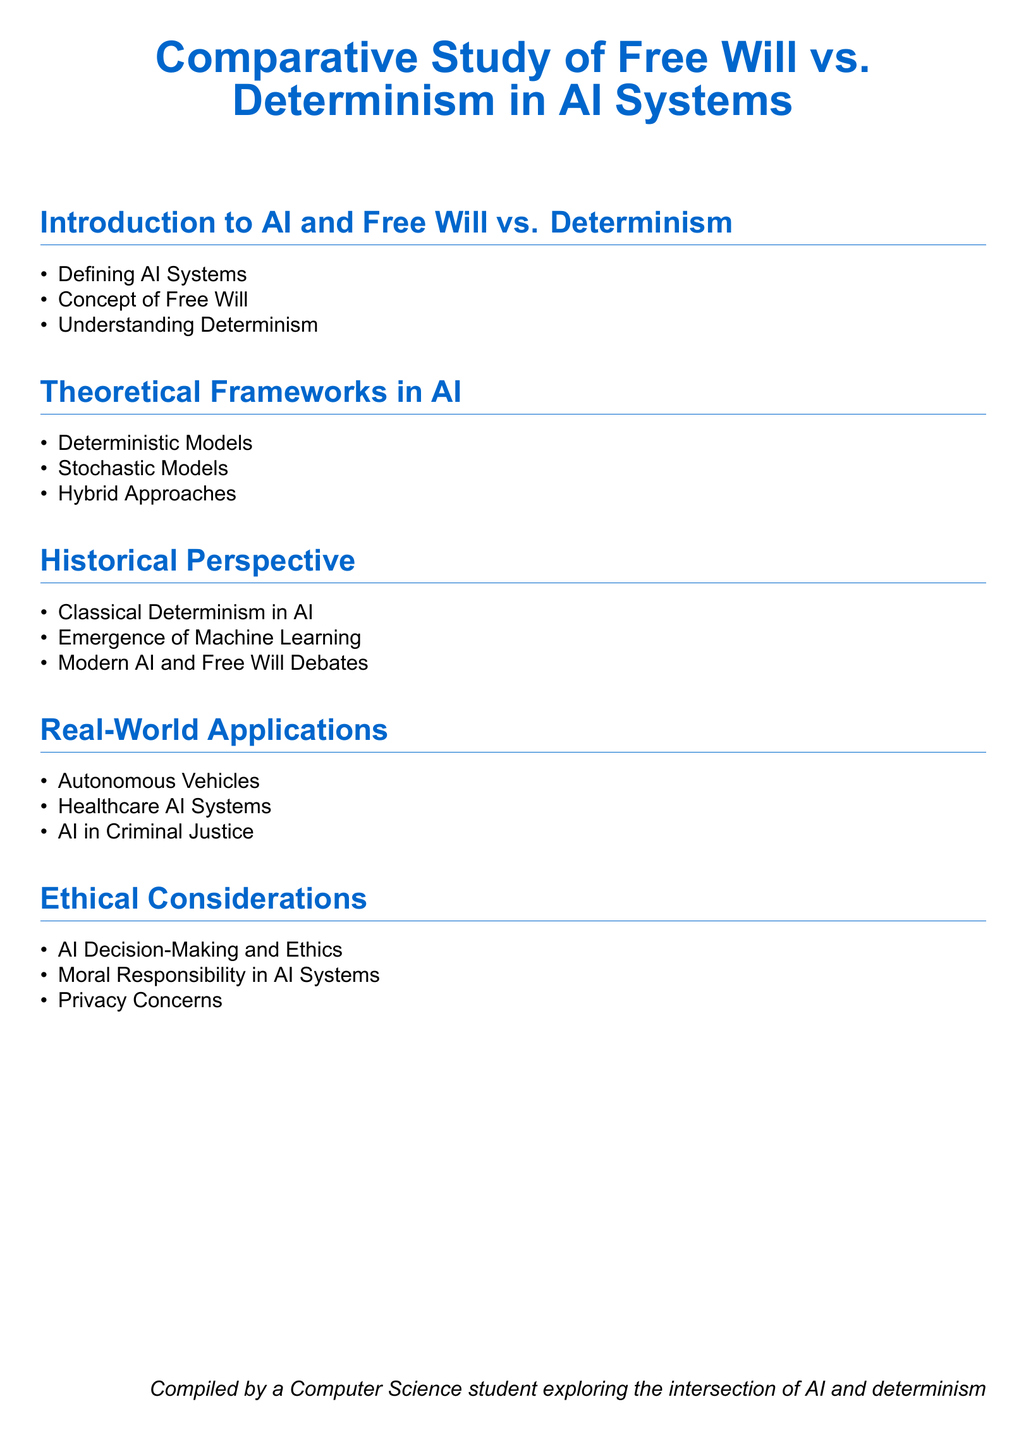what is the main topic of the document? The main topic is described in the title of the document which covers free will and determinism in the context of AI systems.
Answer: Comparative Study of Free Will vs. Determinism in AI Systems how many sections are in the document? The sections are numbered in the document, with five distinct areas being mentioned.
Answer: 5 what does AI stand for? AI is defined in the introduction section of the document as Artificial Intelligence.
Answer: Artificial Intelligence which real-world application is mentioned first? The list of real-world applications starts with Autonomous Vehicles.
Answer: Autonomous Vehicles what are the two types of models discussed in the theoretical frameworks? The theoretical frameworks section lists deterministic and stochastic models as two types.
Answer: Deterministic Models, Stochastic Models who compiled the document? At the end of the document, it states who compiled it and their background.
Answer: A Computer Science student exploring the intersection of AI and determinism what ethical consideration is mentioned last? The ethical considerations section contains three items, the last being Privacy Concerns.
Answer: Privacy Concerns which historical development in AI is addressed second? The historical perspective discusses the emergence of machine learning as the second development.
Answer: Emergence of Machine Learning what color is used for section titles? The document specifies the color used for section titles within the formatting details.
Answer: maincolor (RGB 0,102,204) 